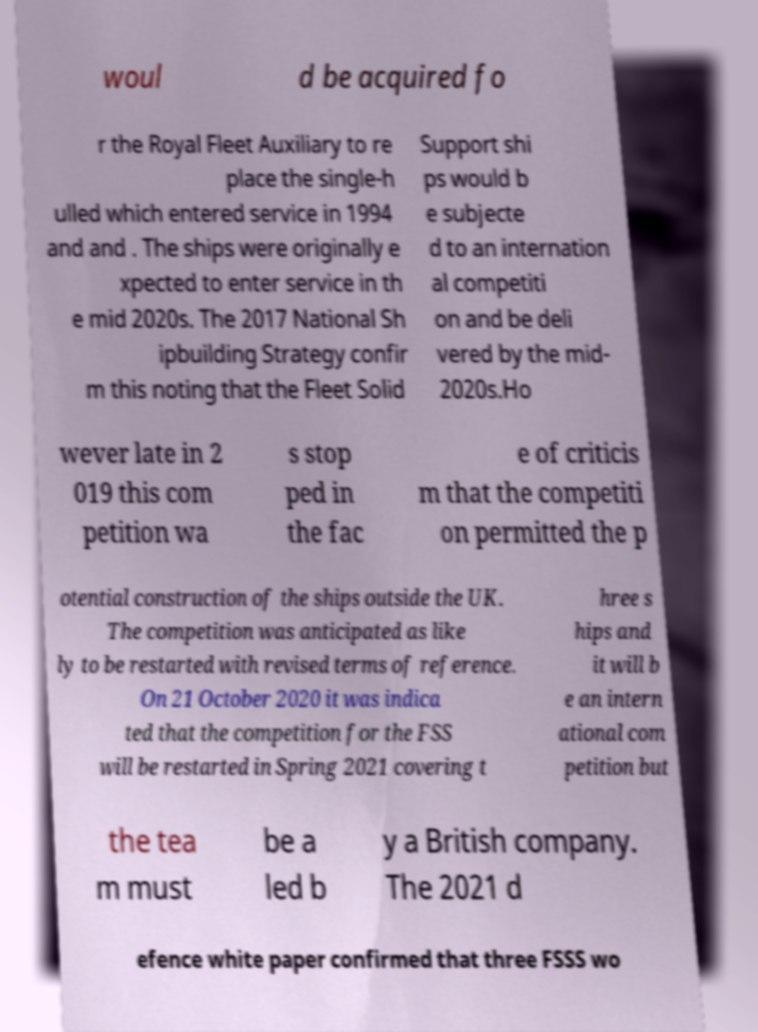I need the written content from this picture converted into text. Can you do that? woul d be acquired fo r the Royal Fleet Auxiliary to re place the single-h ulled which entered service in 1994 and and . The ships were originally e xpected to enter service in th e mid 2020s. The 2017 National Sh ipbuilding Strategy confir m this noting that the Fleet Solid Support shi ps would b e subjecte d to an internation al competiti on and be deli vered by the mid- 2020s.Ho wever late in 2 019 this com petition wa s stop ped in the fac e of criticis m that the competiti on permitted the p otential construction of the ships outside the UK. The competition was anticipated as like ly to be restarted with revised terms of reference. On 21 October 2020 it was indica ted that the competition for the FSS will be restarted in Spring 2021 covering t hree s hips and it will b e an intern ational com petition but the tea m must be a led b y a British company. The 2021 d efence white paper confirmed that three FSSS wo 